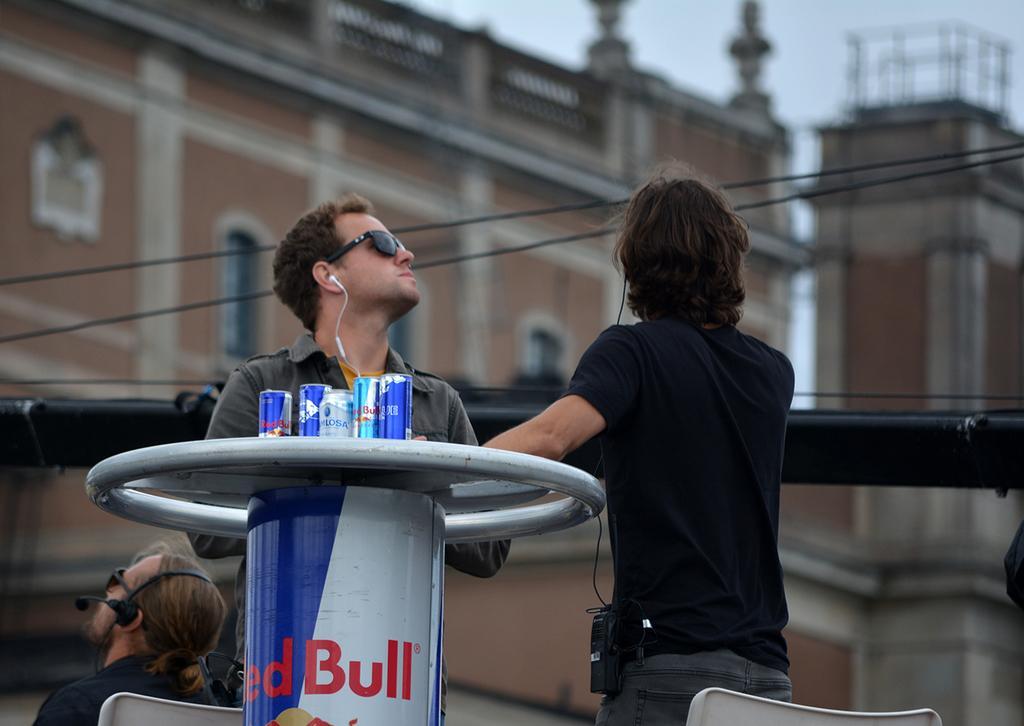How would you summarize this image in a sentence or two? There are two people standing and this man sitting on chair and wired headset and glasses,in front of this man we can see twins on the table. In the background we can see buildings,wires and sky. 